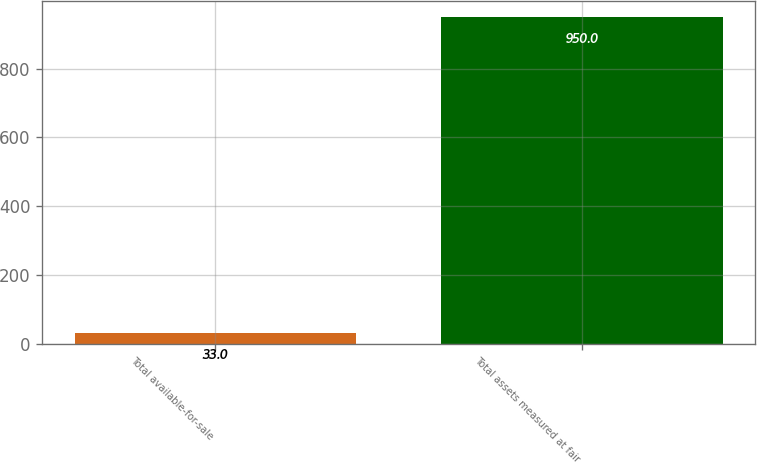Convert chart to OTSL. <chart><loc_0><loc_0><loc_500><loc_500><bar_chart><fcel>Total available-for-sale<fcel>Total assets measured at fair<nl><fcel>33<fcel>950<nl></chart> 